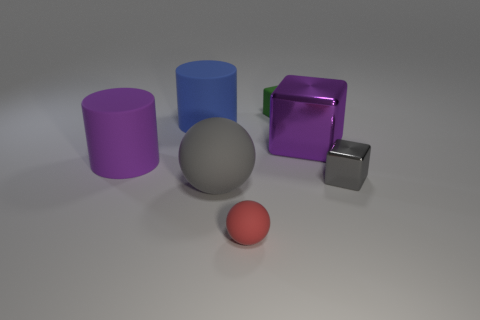Add 3 big purple blocks. How many objects exist? 10 Subtract all blocks. How many objects are left? 4 Add 2 large blue objects. How many large blue objects exist? 3 Subtract 0 green cylinders. How many objects are left? 7 Subtract all tiny red metallic spheres. Subtract all small red rubber balls. How many objects are left? 6 Add 6 large purple cylinders. How many large purple cylinders are left? 7 